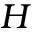<formula> <loc_0><loc_0><loc_500><loc_500>H</formula> 